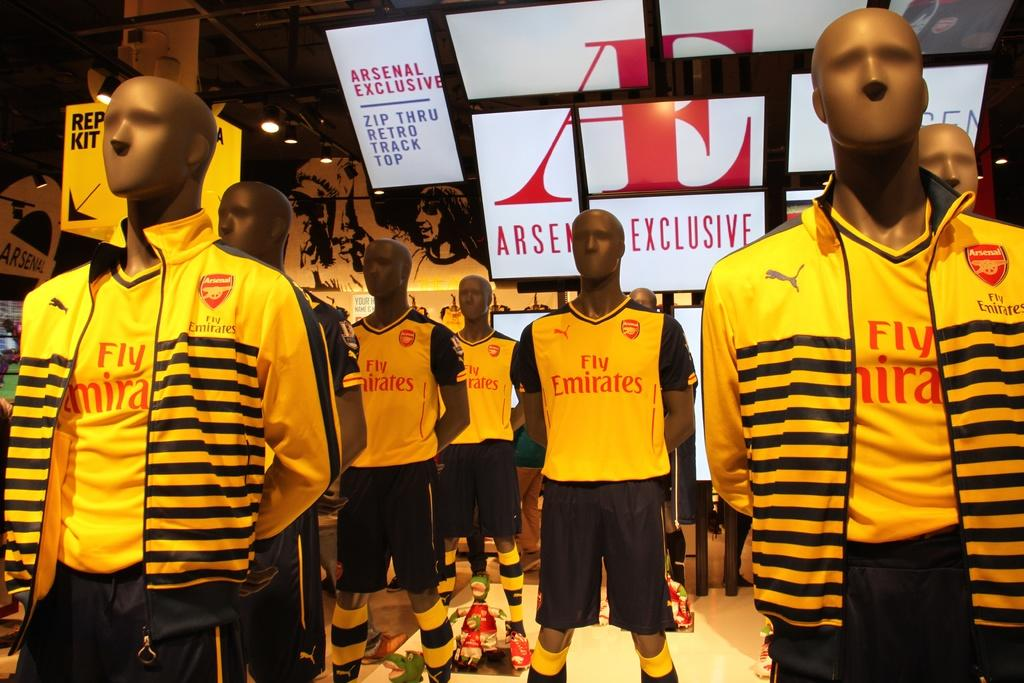<image>
Offer a succinct explanation of the picture presented. A group of mannequins all wear matching Fly Emirates shirts and striped yellow jackets. 